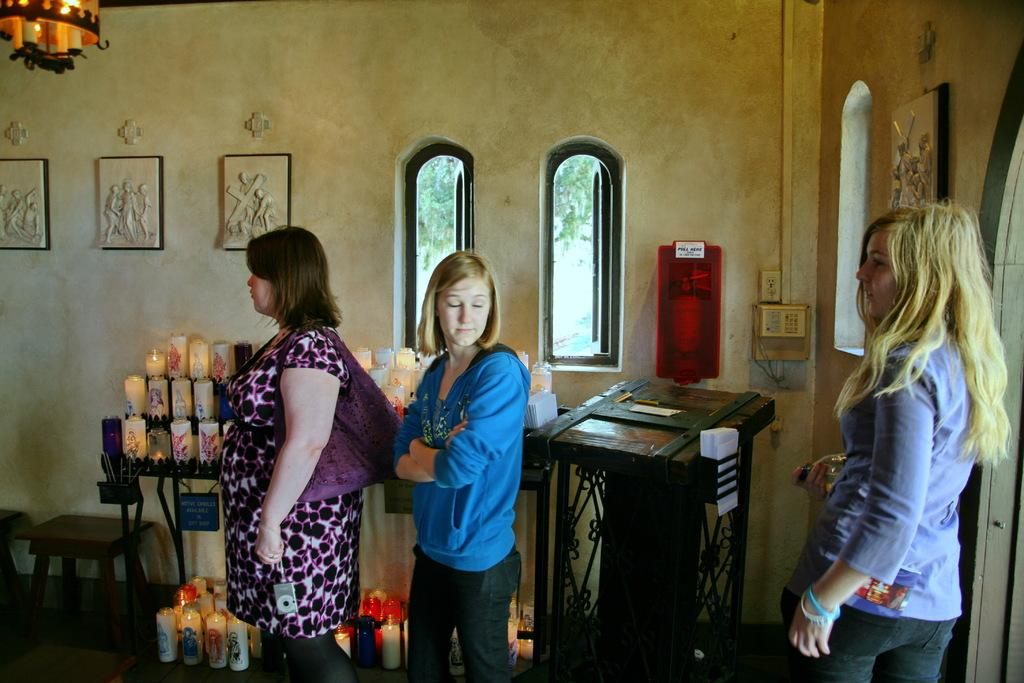How many women are present in the image? There are three women in the image. What object can be used for sitting in the image? There is a stool in the image. What is the source of light in the image? A candle is placed in the image. What type of structure is visible in the image? There is a wall in the image. How many openings are there for light to enter the room in the image? There are two windows in the image. What object might be used for public speaking in the image? There is a podium in the image. What type of drink is being served at the nation's humor event in the image? There is no mention of a drink, nation, or humor event in the image; it features three women, a stool, a candle, a wall, two windows, and a podium. 